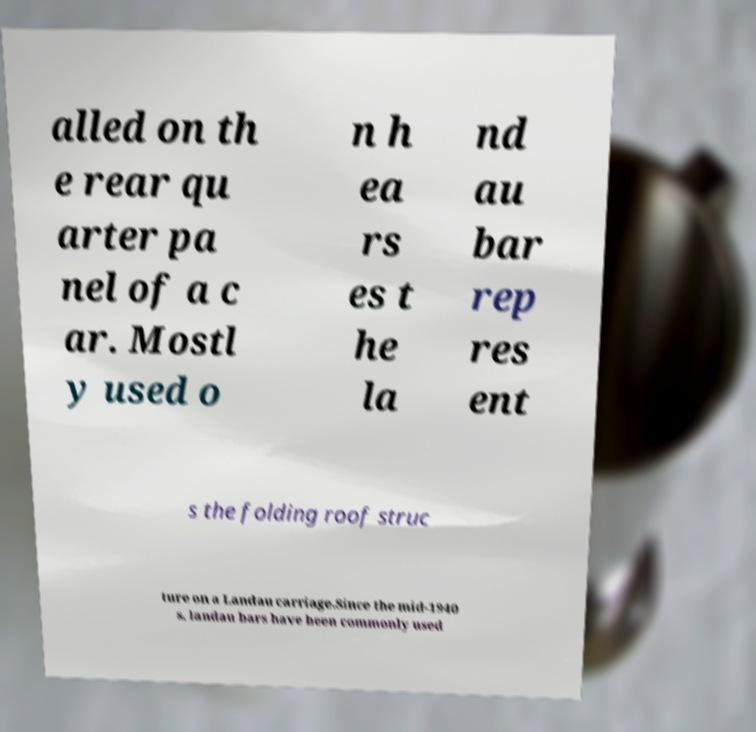There's text embedded in this image that I need extracted. Can you transcribe it verbatim? alled on th e rear qu arter pa nel of a c ar. Mostl y used o n h ea rs es t he la nd au bar rep res ent s the folding roof struc ture on a Landau carriage.Since the mid-1940 s, landau bars have been commonly used 